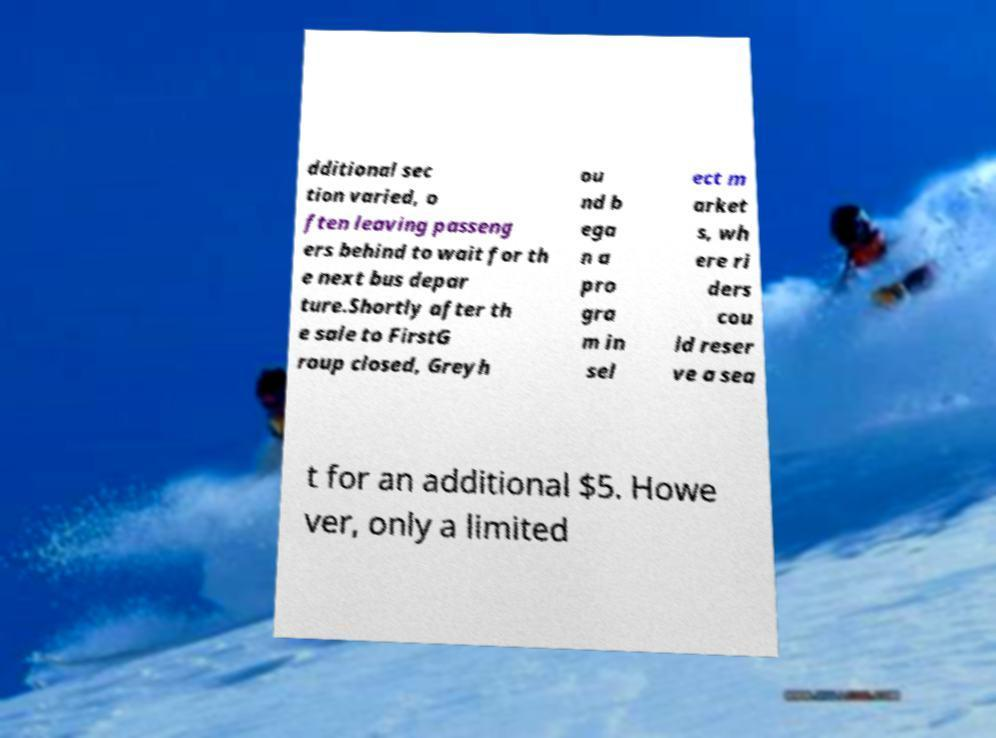What messages or text are displayed in this image? I need them in a readable, typed format. dditional sec tion varied, o ften leaving passeng ers behind to wait for th e next bus depar ture.Shortly after th e sale to FirstG roup closed, Greyh ou nd b ega n a pro gra m in sel ect m arket s, wh ere ri ders cou ld reser ve a sea t for an additional $5. Howe ver, only a limited 